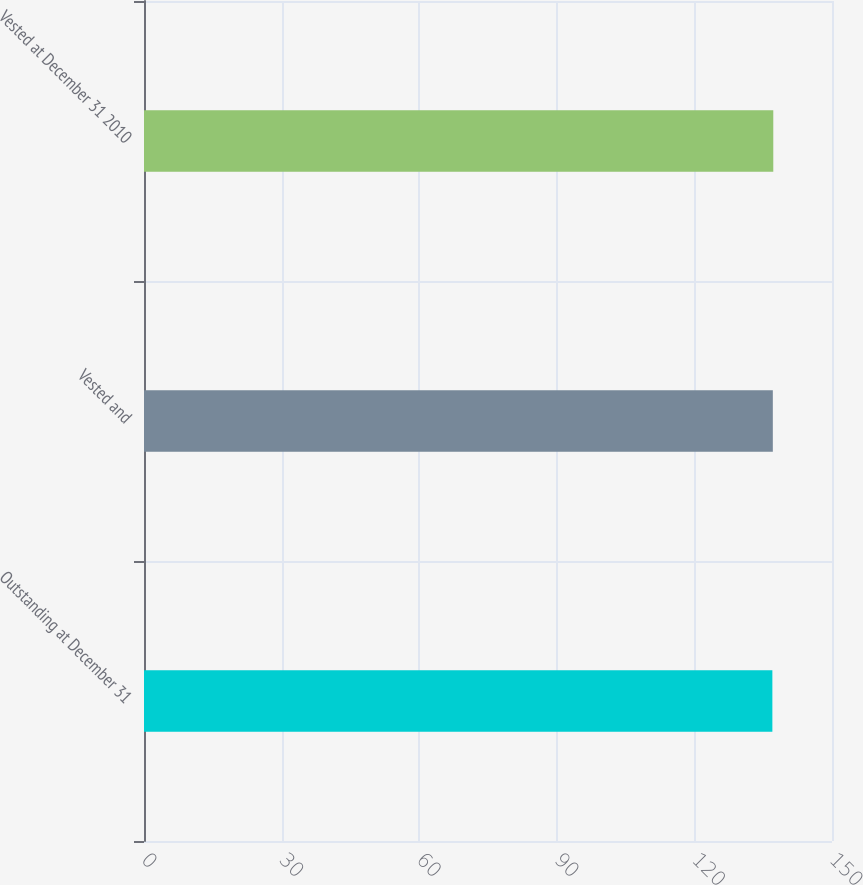Convert chart to OTSL. <chart><loc_0><loc_0><loc_500><loc_500><bar_chart><fcel>Outstanding at December 31<fcel>Vested and<fcel>Vested at December 31 2010<nl><fcel>137<fcel>137.1<fcel>137.2<nl></chart> 